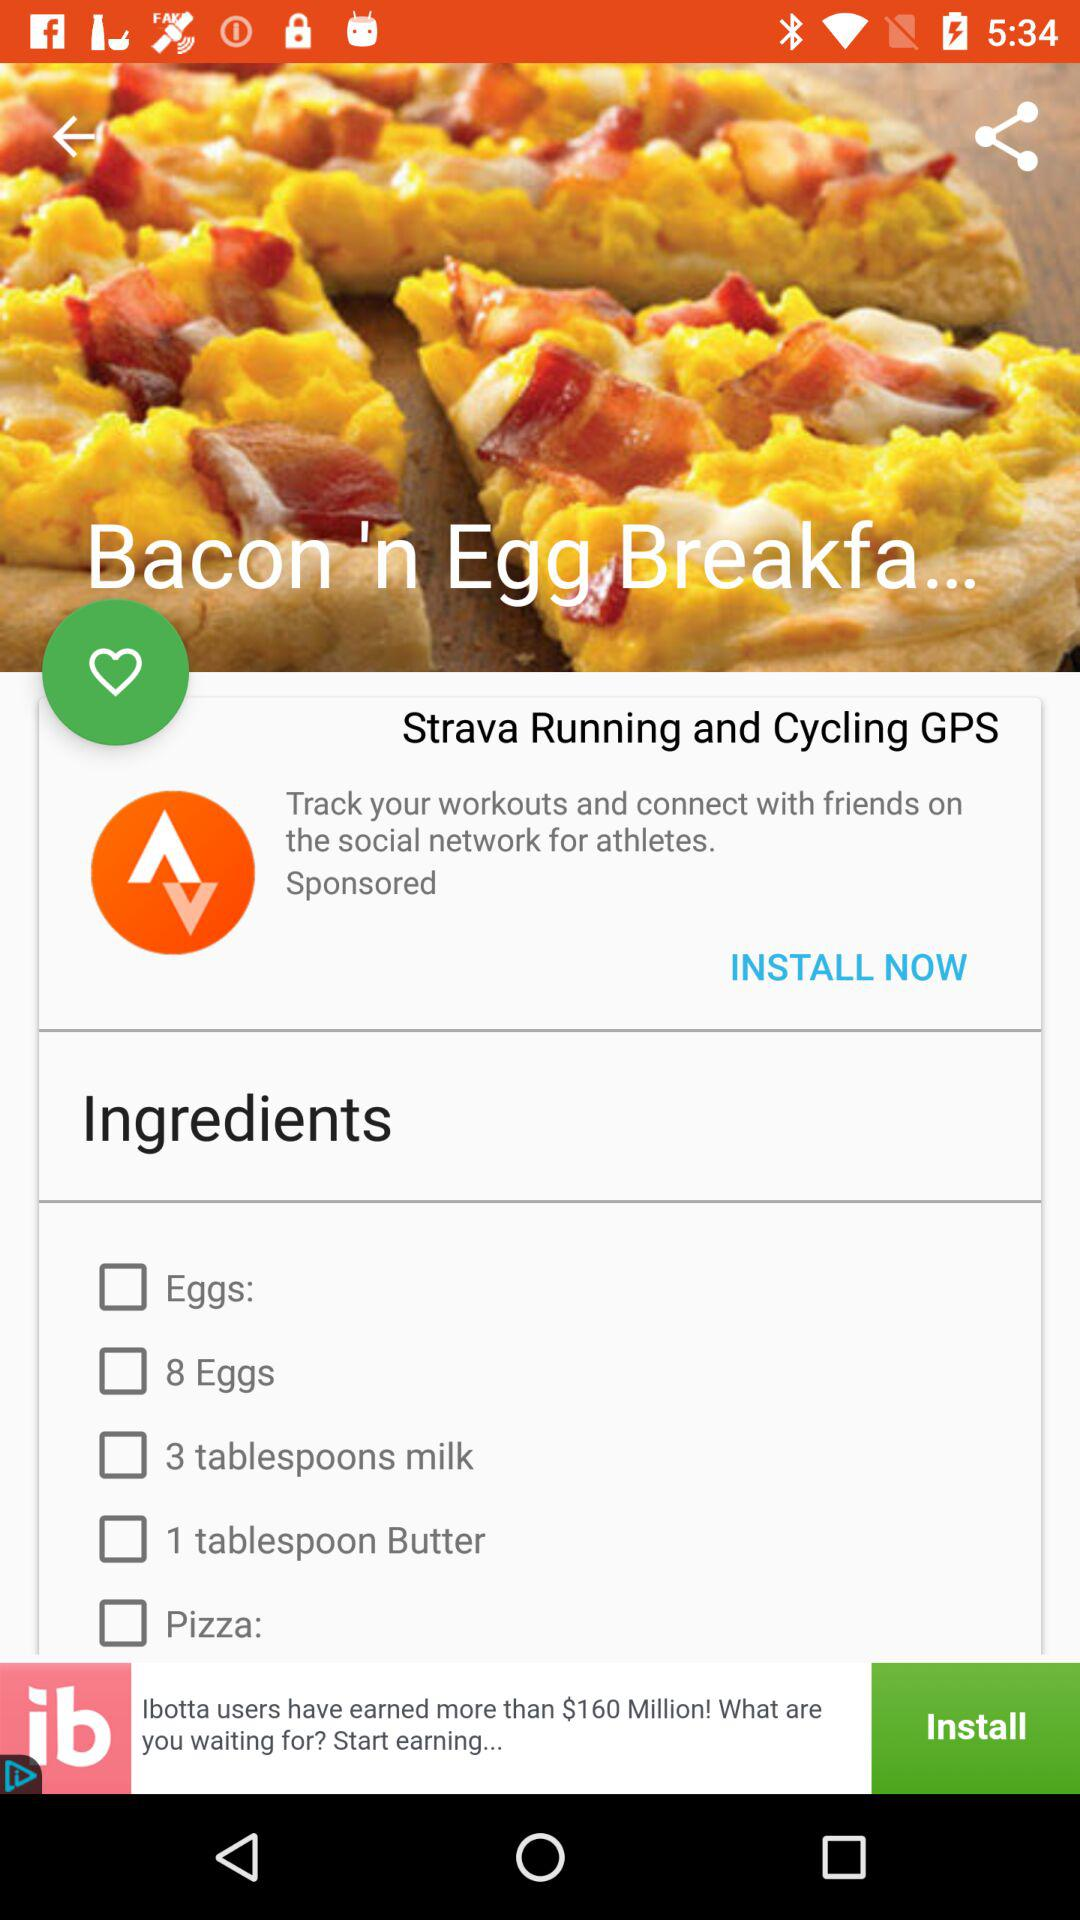What is the name of the dish? The name of the dish is "Bacon 'n Egg Breakfa...". 